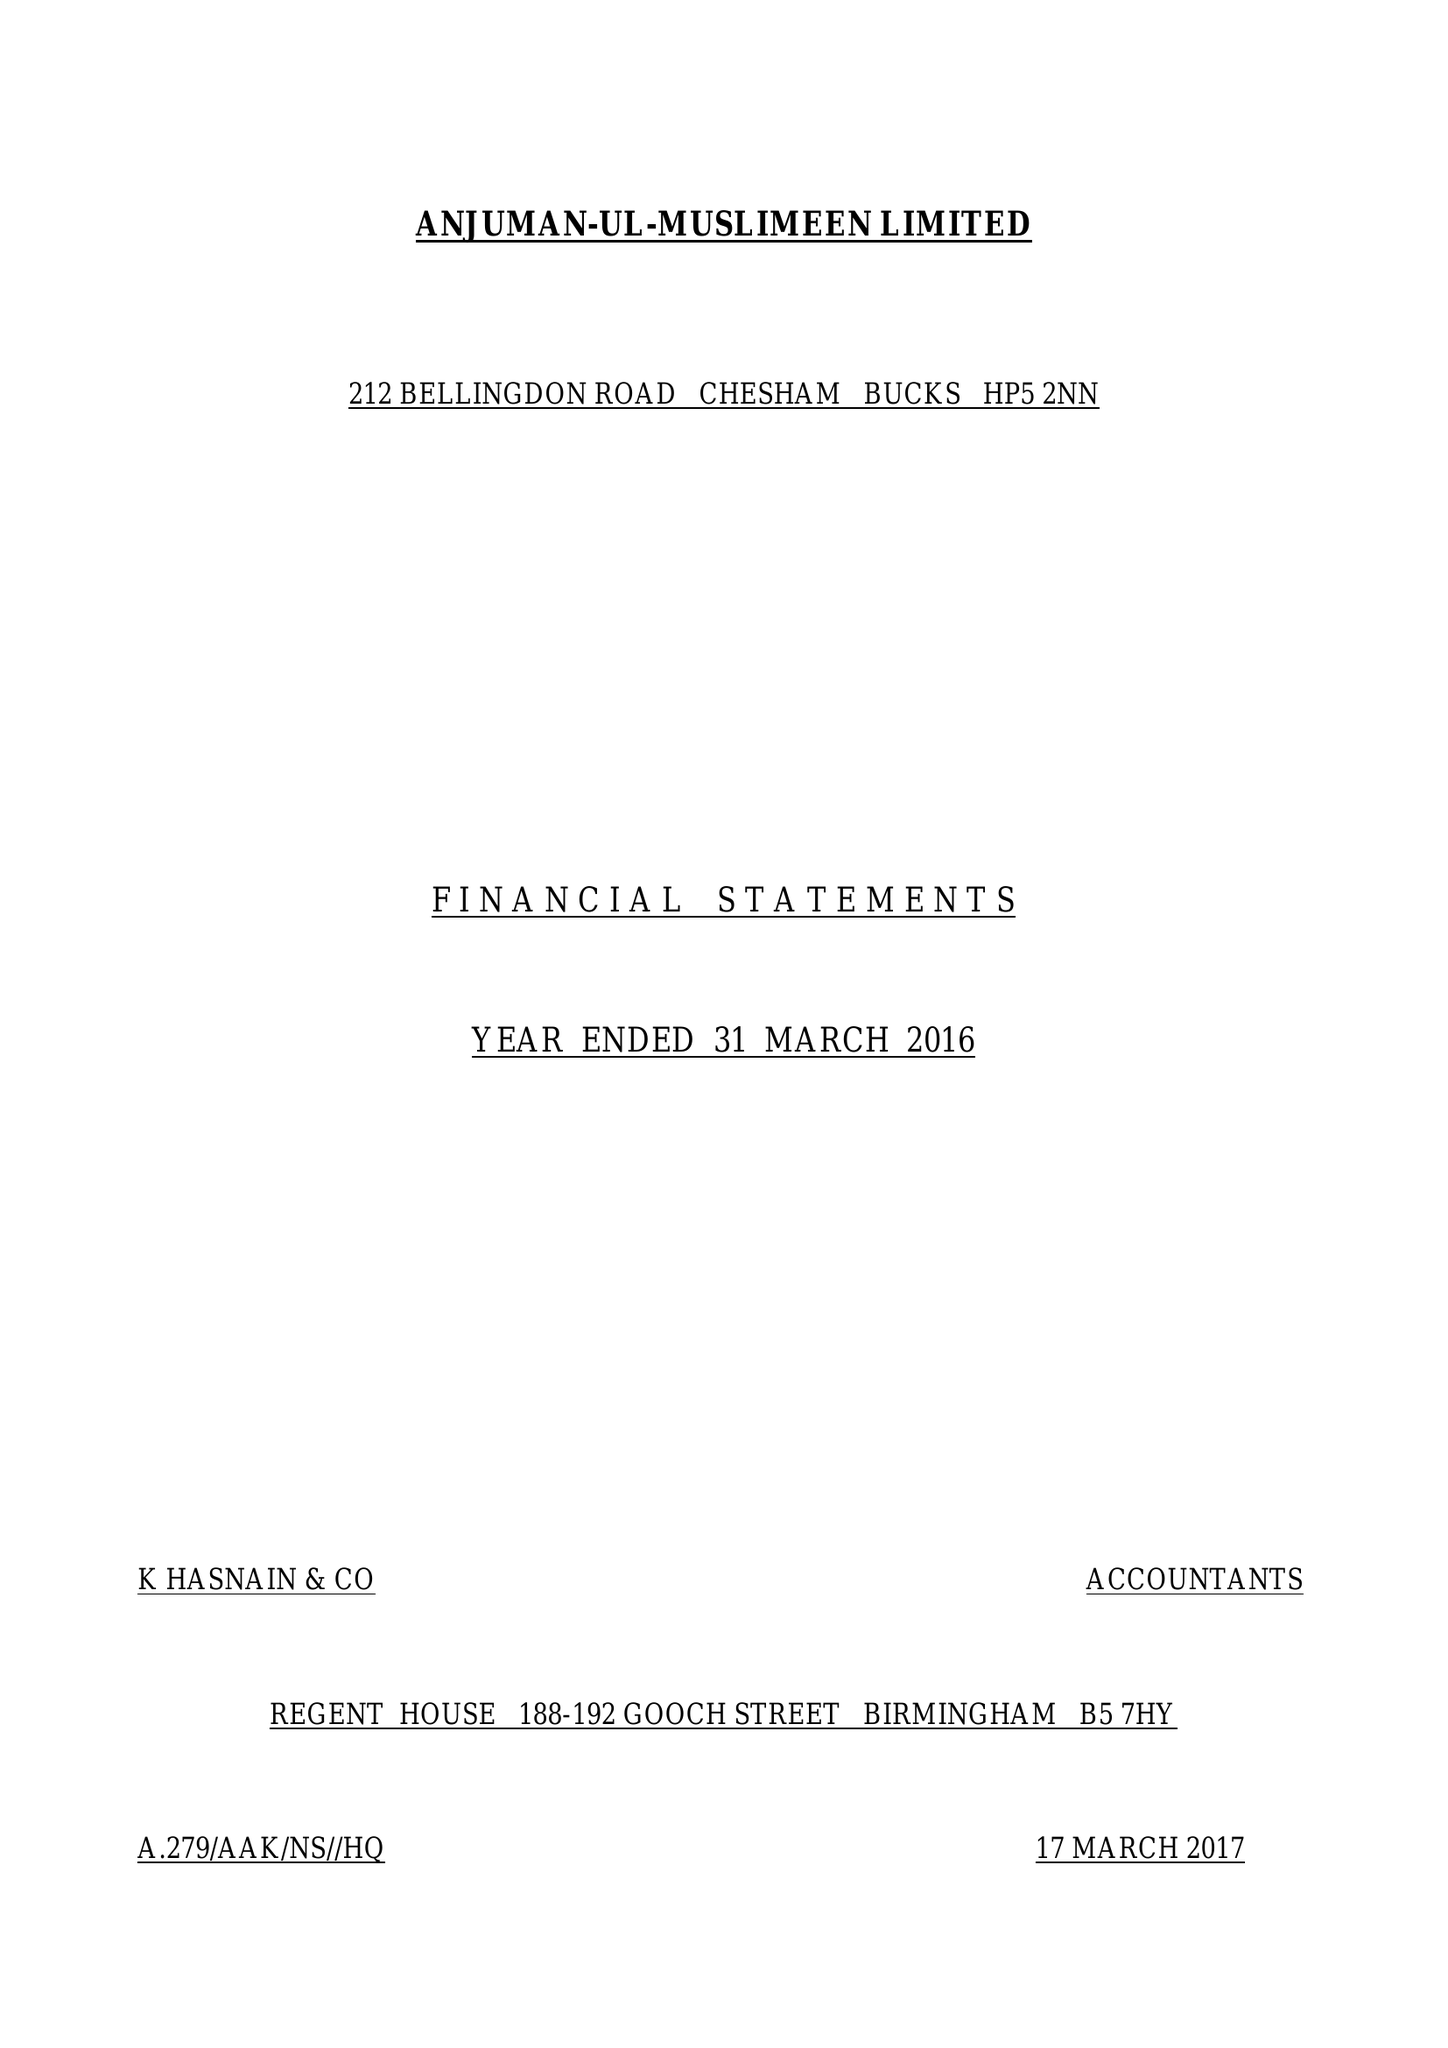What is the value for the charity_name?
Answer the question using a single word or phrase. Anjuman-Ul-Muslimeen Ltd. 